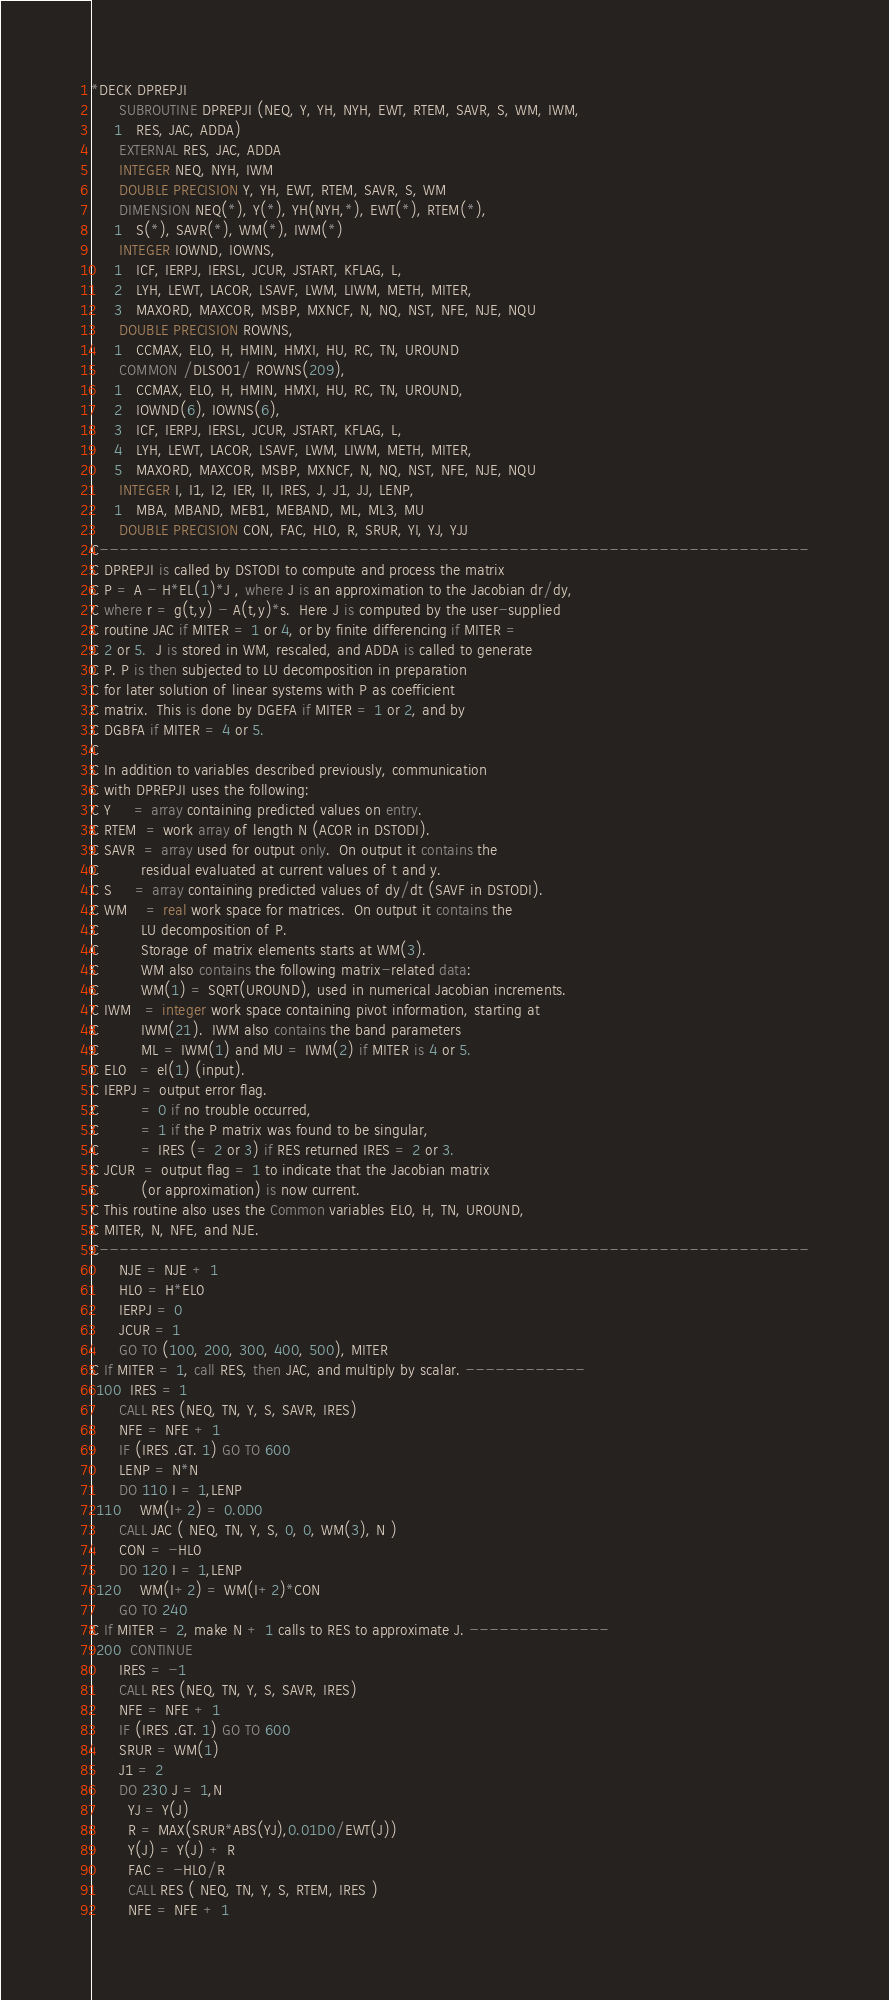<code> <loc_0><loc_0><loc_500><loc_500><_FORTRAN_>*DECK DPREPJI
      SUBROUTINE DPREPJI (NEQ, Y, YH, NYH, EWT, RTEM, SAVR, S, WM, IWM,
     1   RES, JAC, ADDA)
      EXTERNAL RES, JAC, ADDA
      INTEGER NEQ, NYH, IWM
      DOUBLE PRECISION Y, YH, EWT, RTEM, SAVR, S, WM
      DIMENSION NEQ(*), Y(*), YH(NYH,*), EWT(*), RTEM(*),
     1   S(*), SAVR(*), WM(*), IWM(*)
      INTEGER IOWND, IOWNS,
     1   ICF, IERPJ, IERSL, JCUR, JSTART, KFLAG, L,
     2   LYH, LEWT, LACOR, LSAVF, LWM, LIWM, METH, MITER,
     3   MAXORD, MAXCOR, MSBP, MXNCF, N, NQ, NST, NFE, NJE, NQU
      DOUBLE PRECISION ROWNS,
     1   CCMAX, EL0, H, HMIN, HMXI, HU, RC, TN, UROUND
      COMMON /DLS001/ ROWNS(209),
     1   CCMAX, EL0, H, HMIN, HMXI, HU, RC, TN, UROUND,
     2   IOWND(6), IOWNS(6),
     3   ICF, IERPJ, IERSL, JCUR, JSTART, KFLAG, L,
     4   LYH, LEWT, LACOR, LSAVF, LWM, LIWM, METH, MITER,
     5   MAXORD, MAXCOR, MSBP, MXNCF, N, NQ, NST, NFE, NJE, NQU
      INTEGER I, I1, I2, IER, II, IRES, J, J1, JJ, LENP,
     1   MBA, MBAND, MEB1, MEBAND, ML, ML3, MU
      DOUBLE PRECISION CON, FAC, HL0, R, SRUR, YI, YJ, YJJ
C-----------------------------------------------------------------------
C DPREPJI is called by DSTODI to compute and process the matrix
C P = A - H*EL(1)*J , where J is an approximation to the Jacobian dr/dy,
C where r = g(t,y) - A(t,y)*s.  Here J is computed by the user-supplied
C routine JAC if MITER = 1 or 4, or by finite differencing if MITER =
C 2 or 5.  J is stored in WM, rescaled, and ADDA is called to generate
C P. P is then subjected to LU decomposition in preparation
C for later solution of linear systems with P as coefficient
C matrix.  This is done by DGEFA if MITER = 1 or 2, and by
C DGBFA if MITER = 4 or 5.
C
C In addition to variables described previously, communication
C with DPREPJI uses the following:
C Y     = array containing predicted values on entry.
C RTEM  = work array of length N (ACOR in DSTODI).
C SAVR  = array used for output only.  On output it contains the
C         residual evaluated at current values of t and y.
C S     = array containing predicted values of dy/dt (SAVF in DSTODI).
C WM    = real work space for matrices.  On output it contains the
C         LU decomposition of P.
C         Storage of matrix elements starts at WM(3).
C         WM also contains the following matrix-related data:
C         WM(1) = SQRT(UROUND), used in numerical Jacobian increments.
C IWM   = integer work space containing pivot information, starting at
C         IWM(21).  IWM also contains the band parameters
C         ML = IWM(1) and MU = IWM(2) if MITER is 4 or 5.
C EL0   = el(1) (input).
C IERPJ = output error flag.
C         = 0 if no trouble occurred,
C         = 1 if the P matrix was found to be singular,
C         = IRES (= 2 or 3) if RES returned IRES = 2 or 3.
C JCUR  = output flag = 1 to indicate that the Jacobian matrix
C         (or approximation) is now current.
C This routine also uses the Common variables EL0, H, TN, UROUND,
C MITER, N, NFE, and NJE.
C-----------------------------------------------------------------------
      NJE = NJE + 1
      HL0 = H*EL0
      IERPJ = 0
      JCUR = 1
      GO TO (100, 200, 300, 400, 500), MITER
C If MITER = 1, call RES, then JAC, and multiply by scalar. ------------
 100  IRES = 1
      CALL RES (NEQ, TN, Y, S, SAVR, IRES)
      NFE = NFE + 1
      IF (IRES .GT. 1) GO TO 600
      LENP = N*N
      DO 110 I = 1,LENP
 110    WM(I+2) = 0.0D0
      CALL JAC ( NEQ, TN, Y, S, 0, 0, WM(3), N )
      CON = -HL0
      DO 120 I = 1,LENP
 120    WM(I+2) = WM(I+2)*CON
      GO TO 240
C If MITER = 2, make N + 1 calls to RES to approximate J. --------------
 200  CONTINUE
      IRES = -1
      CALL RES (NEQ, TN, Y, S, SAVR, IRES)
      NFE = NFE + 1
      IF (IRES .GT. 1) GO TO 600
      SRUR = WM(1)
      J1 = 2
      DO 230 J = 1,N
        YJ = Y(J)
        R = MAX(SRUR*ABS(YJ),0.01D0/EWT(J))
        Y(J) = Y(J) + R
        FAC = -HL0/R
        CALL RES ( NEQ, TN, Y, S, RTEM, IRES )
        NFE = NFE + 1</code> 